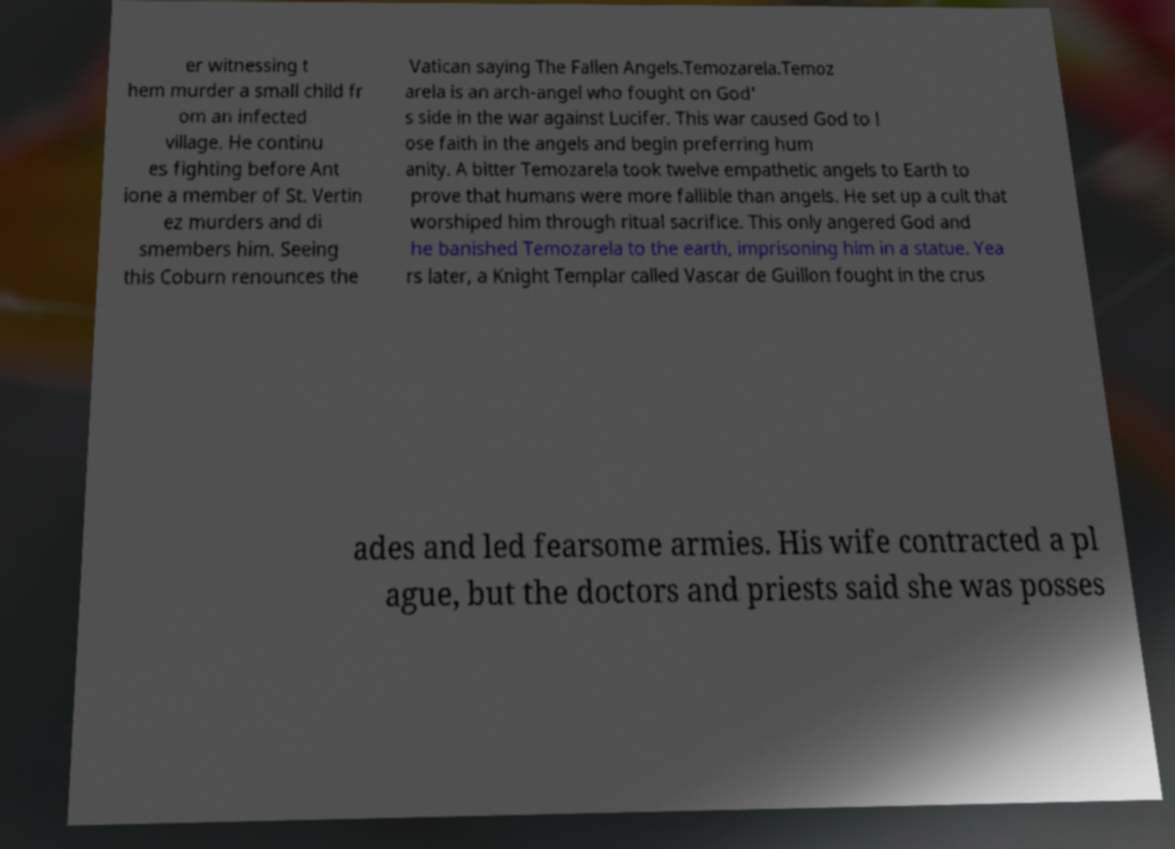Can you read and provide the text displayed in the image?This photo seems to have some interesting text. Can you extract and type it out for me? er witnessing t hem murder a small child fr om an infected village. He continu es fighting before Ant ione a member of St. Vertin ez murders and di smembers him. Seeing this Coburn renounces the Vatican saying The Fallen Angels.Temozarela.Temoz arela is an arch-angel who fought on God' s side in the war against Lucifer. This war caused God to l ose faith in the angels and begin preferring hum anity. A bitter Temozarela took twelve empathetic angels to Earth to prove that humans were more fallible than angels. He set up a cult that worshiped him through ritual sacrifice. This only angered God and he banished Temozarela to the earth, imprisoning him in a statue. Yea rs later, a Knight Templar called Vascar de Guillon fought in the crus ades and led fearsome armies. His wife contracted a pl ague, but the doctors and priests said she was posses 